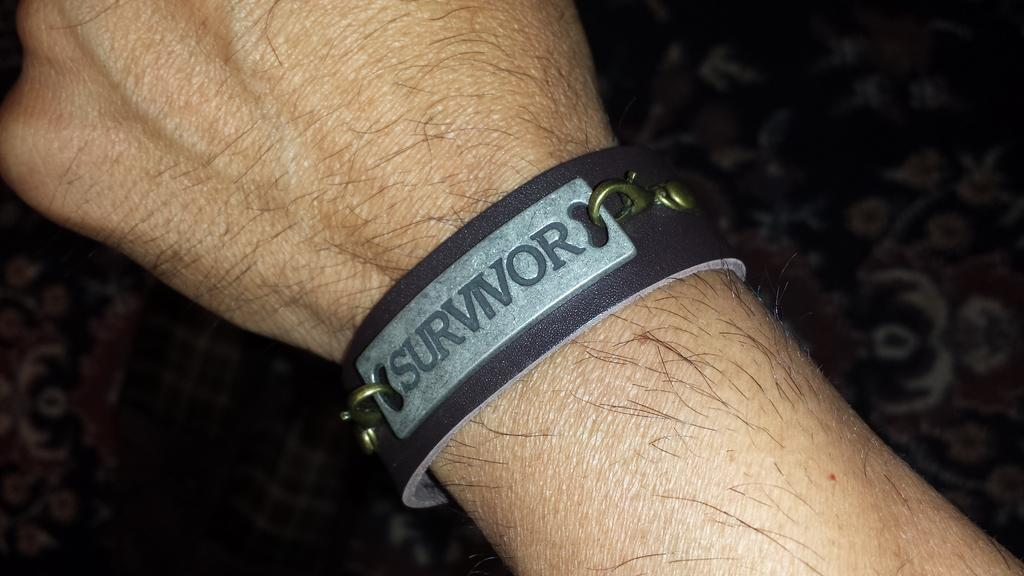What is on the person's hand in the image? There is a band on the person's hand in the image. What is written on the band? The name "survivor" is written on the band. What is the color scheme of the image? The background of the image is black and white. How does the person's sister feel about the lettuce in the image? There is no mention of a sister or lettuce in the image, so it is impossible to determine how the person's sister feels about lettuce. 